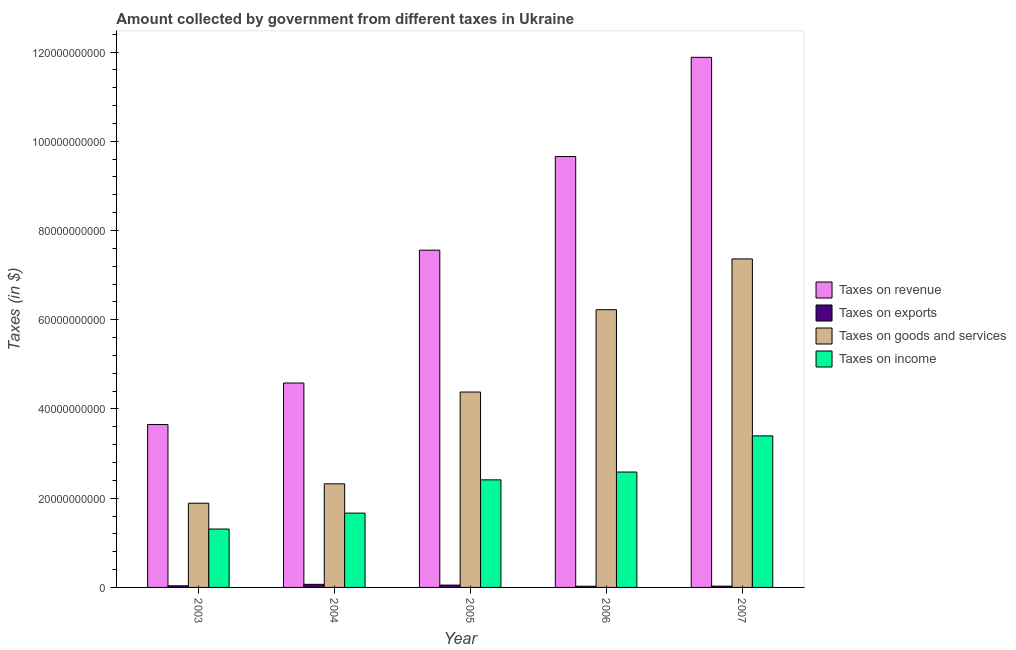How many bars are there on the 3rd tick from the left?
Make the answer very short. 4. In how many cases, is the number of bars for a given year not equal to the number of legend labels?
Your answer should be very brief. 0. What is the amount collected as tax on goods in 2004?
Ensure brevity in your answer.  2.32e+1. Across all years, what is the maximum amount collected as tax on goods?
Keep it short and to the point. 7.36e+1. Across all years, what is the minimum amount collected as tax on income?
Your answer should be very brief. 1.31e+1. In which year was the amount collected as tax on revenue minimum?
Keep it short and to the point. 2003. What is the total amount collected as tax on goods in the graph?
Give a very brief answer. 2.22e+11. What is the difference between the amount collected as tax on revenue in 2004 and that in 2006?
Your answer should be very brief. -5.08e+1. What is the difference between the amount collected as tax on income in 2007 and the amount collected as tax on exports in 2006?
Ensure brevity in your answer.  8.10e+09. What is the average amount collected as tax on revenue per year?
Ensure brevity in your answer.  7.47e+1. In how many years, is the amount collected as tax on income greater than 44000000000 $?
Keep it short and to the point. 0. What is the ratio of the amount collected as tax on income in 2003 to that in 2006?
Offer a terse response. 0.51. Is the amount collected as tax on goods in 2003 less than that in 2004?
Make the answer very short. Yes. Is the difference between the amount collected as tax on revenue in 2005 and 2006 greater than the difference between the amount collected as tax on income in 2005 and 2006?
Offer a terse response. No. What is the difference between the highest and the second highest amount collected as tax on goods?
Provide a short and direct response. 1.14e+1. What is the difference between the highest and the lowest amount collected as tax on revenue?
Keep it short and to the point. 8.23e+1. In how many years, is the amount collected as tax on income greater than the average amount collected as tax on income taken over all years?
Provide a short and direct response. 3. Is it the case that in every year, the sum of the amount collected as tax on goods and amount collected as tax on exports is greater than the sum of amount collected as tax on revenue and amount collected as tax on income?
Your answer should be compact. No. What does the 4th bar from the left in 2004 represents?
Offer a terse response. Taxes on income. What does the 2nd bar from the right in 2006 represents?
Ensure brevity in your answer.  Taxes on goods and services. Is it the case that in every year, the sum of the amount collected as tax on revenue and amount collected as tax on exports is greater than the amount collected as tax on goods?
Your response must be concise. Yes. Are all the bars in the graph horizontal?
Ensure brevity in your answer.  No. Does the graph contain grids?
Your answer should be compact. No. How many legend labels are there?
Ensure brevity in your answer.  4. How are the legend labels stacked?
Your answer should be very brief. Vertical. What is the title of the graph?
Give a very brief answer. Amount collected by government from different taxes in Ukraine. What is the label or title of the X-axis?
Offer a very short reply. Year. What is the label or title of the Y-axis?
Your answer should be compact. Taxes (in $). What is the Taxes (in $) of Taxes on revenue in 2003?
Your response must be concise. 3.65e+1. What is the Taxes (in $) of Taxes on exports in 2003?
Offer a very short reply. 3.64e+08. What is the Taxes (in $) of Taxes on goods and services in 2003?
Keep it short and to the point. 1.89e+1. What is the Taxes (in $) in Taxes on income in 2003?
Ensure brevity in your answer.  1.31e+1. What is the Taxes (in $) in Taxes on revenue in 2004?
Offer a very short reply. 4.58e+1. What is the Taxes (in $) in Taxes on exports in 2004?
Your response must be concise. 6.92e+08. What is the Taxes (in $) in Taxes on goods and services in 2004?
Provide a succinct answer. 2.32e+1. What is the Taxes (in $) of Taxes on income in 2004?
Ensure brevity in your answer.  1.67e+1. What is the Taxes (in $) of Taxes on revenue in 2005?
Keep it short and to the point. 7.56e+1. What is the Taxes (in $) in Taxes on exports in 2005?
Make the answer very short. 5.20e+08. What is the Taxes (in $) in Taxes on goods and services in 2005?
Keep it short and to the point. 4.38e+1. What is the Taxes (in $) in Taxes on income in 2005?
Offer a terse response. 2.41e+1. What is the Taxes (in $) of Taxes on revenue in 2006?
Your response must be concise. 9.66e+1. What is the Taxes (in $) of Taxes on exports in 2006?
Your answer should be very brief. 2.70e+08. What is the Taxes (in $) in Taxes on goods and services in 2006?
Give a very brief answer. 6.22e+1. What is the Taxes (in $) of Taxes on income in 2006?
Your answer should be compact. 2.59e+1. What is the Taxes (in $) of Taxes on revenue in 2007?
Your response must be concise. 1.19e+11. What is the Taxes (in $) in Taxes on exports in 2007?
Ensure brevity in your answer.  2.91e+08. What is the Taxes (in $) of Taxes on goods and services in 2007?
Your response must be concise. 7.36e+1. What is the Taxes (in $) of Taxes on income in 2007?
Ensure brevity in your answer.  3.40e+1. Across all years, what is the maximum Taxes (in $) of Taxes on revenue?
Offer a terse response. 1.19e+11. Across all years, what is the maximum Taxes (in $) in Taxes on exports?
Keep it short and to the point. 6.92e+08. Across all years, what is the maximum Taxes (in $) in Taxes on goods and services?
Provide a succinct answer. 7.36e+1. Across all years, what is the maximum Taxes (in $) of Taxes on income?
Offer a terse response. 3.40e+1. Across all years, what is the minimum Taxes (in $) of Taxes on revenue?
Your answer should be very brief. 3.65e+1. Across all years, what is the minimum Taxes (in $) of Taxes on exports?
Offer a very short reply. 2.70e+08. Across all years, what is the minimum Taxes (in $) in Taxes on goods and services?
Offer a terse response. 1.89e+1. Across all years, what is the minimum Taxes (in $) of Taxes on income?
Keep it short and to the point. 1.31e+1. What is the total Taxes (in $) in Taxes on revenue in the graph?
Your answer should be very brief. 3.73e+11. What is the total Taxes (in $) in Taxes on exports in the graph?
Offer a terse response. 2.14e+09. What is the total Taxes (in $) in Taxes on goods and services in the graph?
Provide a succinct answer. 2.22e+11. What is the total Taxes (in $) in Taxes on income in the graph?
Your answer should be compact. 1.14e+11. What is the difference between the Taxes (in $) in Taxes on revenue in 2003 and that in 2004?
Offer a terse response. -9.31e+09. What is the difference between the Taxes (in $) of Taxes on exports in 2003 and that in 2004?
Your answer should be compact. -3.27e+08. What is the difference between the Taxes (in $) of Taxes on goods and services in 2003 and that in 2004?
Offer a terse response. -4.34e+09. What is the difference between the Taxes (in $) in Taxes on income in 2003 and that in 2004?
Offer a terse response. -3.57e+09. What is the difference between the Taxes (in $) of Taxes on revenue in 2003 and that in 2005?
Keep it short and to the point. -3.91e+1. What is the difference between the Taxes (in $) of Taxes on exports in 2003 and that in 2005?
Provide a short and direct response. -1.56e+08. What is the difference between the Taxes (in $) of Taxes on goods and services in 2003 and that in 2005?
Provide a short and direct response. -2.49e+1. What is the difference between the Taxes (in $) of Taxes on income in 2003 and that in 2005?
Offer a very short reply. -1.10e+1. What is the difference between the Taxes (in $) in Taxes on revenue in 2003 and that in 2006?
Provide a short and direct response. -6.01e+1. What is the difference between the Taxes (in $) in Taxes on exports in 2003 and that in 2006?
Offer a terse response. 9.43e+07. What is the difference between the Taxes (in $) in Taxes on goods and services in 2003 and that in 2006?
Make the answer very short. -4.34e+1. What is the difference between the Taxes (in $) in Taxes on income in 2003 and that in 2006?
Provide a short and direct response. -1.28e+1. What is the difference between the Taxes (in $) in Taxes on revenue in 2003 and that in 2007?
Offer a very short reply. -8.23e+1. What is the difference between the Taxes (in $) of Taxes on exports in 2003 and that in 2007?
Make the answer very short. 7.28e+07. What is the difference between the Taxes (in $) in Taxes on goods and services in 2003 and that in 2007?
Provide a short and direct response. -5.48e+1. What is the difference between the Taxes (in $) in Taxes on income in 2003 and that in 2007?
Make the answer very short. -2.09e+1. What is the difference between the Taxes (in $) in Taxes on revenue in 2004 and that in 2005?
Make the answer very short. -2.98e+1. What is the difference between the Taxes (in $) of Taxes on exports in 2004 and that in 2005?
Provide a short and direct response. 1.71e+08. What is the difference between the Taxes (in $) of Taxes on goods and services in 2004 and that in 2005?
Your answer should be compact. -2.06e+1. What is the difference between the Taxes (in $) of Taxes on income in 2004 and that in 2005?
Make the answer very short. -7.45e+09. What is the difference between the Taxes (in $) in Taxes on revenue in 2004 and that in 2006?
Your answer should be very brief. -5.08e+1. What is the difference between the Taxes (in $) in Taxes on exports in 2004 and that in 2006?
Your response must be concise. 4.22e+08. What is the difference between the Taxes (in $) of Taxes on goods and services in 2004 and that in 2006?
Ensure brevity in your answer.  -3.90e+1. What is the difference between the Taxes (in $) of Taxes on income in 2004 and that in 2006?
Your response must be concise. -9.20e+09. What is the difference between the Taxes (in $) of Taxes on revenue in 2004 and that in 2007?
Your answer should be very brief. -7.30e+1. What is the difference between the Taxes (in $) of Taxes on exports in 2004 and that in 2007?
Provide a succinct answer. 4.00e+08. What is the difference between the Taxes (in $) in Taxes on goods and services in 2004 and that in 2007?
Offer a very short reply. -5.04e+1. What is the difference between the Taxes (in $) in Taxes on income in 2004 and that in 2007?
Make the answer very short. -1.73e+1. What is the difference between the Taxes (in $) in Taxes on revenue in 2005 and that in 2006?
Provide a short and direct response. -2.10e+1. What is the difference between the Taxes (in $) in Taxes on exports in 2005 and that in 2006?
Offer a terse response. 2.51e+08. What is the difference between the Taxes (in $) of Taxes on goods and services in 2005 and that in 2006?
Your answer should be very brief. -1.84e+1. What is the difference between the Taxes (in $) in Taxes on income in 2005 and that in 2006?
Ensure brevity in your answer.  -1.75e+09. What is the difference between the Taxes (in $) of Taxes on revenue in 2005 and that in 2007?
Offer a terse response. -4.32e+1. What is the difference between the Taxes (in $) in Taxes on exports in 2005 and that in 2007?
Provide a succinct answer. 2.29e+08. What is the difference between the Taxes (in $) in Taxes on goods and services in 2005 and that in 2007?
Make the answer very short. -2.98e+1. What is the difference between the Taxes (in $) of Taxes on income in 2005 and that in 2007?
Your answer should be very brief. -9.85e+09. What is the difference between the Taxes (in $) in Taxes on revenue in 2006 and that in 2007?
Offer a very short reply. -2.22e+1. What is the difference between the Taxes (in $) in Taxes on exports in 2006 and that in 2007?
Give a very brief answer. -2.15e+07. What is the difference between the Taxes (in $) in Taxes on goods and services in 2006 and that in 2007?
Make the answer very short. -1.14e+1. What is the difference between the Taxes (in $) of Taxes on income in 2006 and that in 2007?
Give a very brief answer. -8.10e+09. What is the difference between the Taxes (in $) of Taxes on revenue in 2003 and the Taxes (in $) of Taxes on exports in 2004?
Provide a succinct answer. 3.58e+1. What is the difference between the Taxes (in $) in Taxes on revenue in 2003 and the Taxes (in $) in Taxes on goods and services in 2004?
Your answer should be compact. 1.33e+1. What is the difference between the Taxes (in $) in Taxes on revenue in 2003 and the Taxes (in $) in Taxes on income in 2004?
Offer a terse response. 1.98e+1. What is the difference between the Taxes (in $) of Taxes on exports in 2003 and the Taxes (in $) of Taxes on goods and services in 2004?
Your response must be concise. -2.29e+1. What is the difference between the Taxes (in $) in Taxes on exports in 2003 and the Taxes (in $) in Taxes on income in 2004?
Your answer should be compact. -1.63e+1. What is the difference between the Taxes (in $) of Taxes on goods and services in 2003 and the Taxes (in $) of Taxes on income in 2004?
Your answer should be compact. 2.22e+09. What is the difference between the Taxes (in $) in Taxes on revenue in 2003 and the Taxes (in $) in Taxes on exports in 2005?
Give a very brief answer. 3.60e+1. What is the difference between the Taxes (in $) of Taxes on revenue in 2003 and the Taxes (in $) of Taxes on goods and services in 2005?
Ensure brevity in your answer.  -7.29e+09. What is the difference between the Taxes (in $) of Taxes on revenue in 2003 and the Taxes (in $) of Taxes on income in 2005?
Make the answer very short. 1.24e+1. What is the difference between the Taxes (in $) of Taxes on exports in 2003 and the Taxes (in $) of Taxes on goods and services in 2005?
Provide a succinct answer. -4.34e+1. What is the difference between the Taxes (in $) of Taxes on exports in 2003 and the Taxes (in $) of Taxes on income in 2005?
Offer a very short reply. -2.37e+1. What is the difference between the Taxes (in $) in Taxes on goods and services in 2003 and the Taxes (in $) in Taxes on income in 2005?
Offer a very short reply. -5.23e+09. What is the difference between the Taxes (in $) in Taxes on revenue in 2003 and the Taxes (in $) in Taxes on exports in 2006?
Offer a terse response. 3.62e+1. What is the difference between the Taxes (in $) in Taxes on revenue in 2003 and the Taxes (in $) in Taxes on goods and services in 2006?
Keep it short and to the point. -2.57e+1. What is the difference between the Taxes (in $) in Taxes on revenue in 2003 and the Taxes (in $) in Taxes on income in 2006?
Keep it short and to the point. 1.06e+1. What is the difference between the Taxes (in $) of Taxes on exports in 2003 and the Taxes (in $) of Taxes on goods and services in 2006?
Your response must be concise. -6.19e+1. What is the difference between the Taxes (in $) of Taxes on exports in 2003 and the Taxes (in $) of Taxes on income in 2006?
Provide a short and direct response. -2.55e+1. What is the difference between the Taxes (in $) of Taxes on goods and services in 2003 and the Taxes (in $) of Taxes on income in 2006?
Ensure brevity in your answer.  -6.99e+09. What is the difference between the Taxes (in $) of Taxes on revenue in 2003 and the Taxes (in $) of Taxes on exports in 2007?
Offer a terse response. 3.62e+1. What is the difference between the Taxes (in $) of Taxes on revenue in 2003 and the Taxes (in $) of Taxes on goods and services in 2007?
Make the answer very short. -3.71e+1. What is the difference between the Taxes (in $) of Taxes on revenue in 2003 and the Taxes (in $) of Taxes on income in 2007?
Provide a short and direct response. 2.54e+09. What is the difference between the Taxes (in $) in Taxes on exports in 2003 and the Taxes (in $) in Taxes on goods and services in 2007?
Your response must be concise. -7.33e+1. What is the difference between the Taxes (in $) of Taxes on exports in 2003 and the Taxes (in $) of Taxes on income in 2007?
Provide a short and direct response. -3.36e+1. What is the difference between the Taxes (in $) of Taxes on goods and services in 2003 and the Taxes (in $) of Taxes on income in 2007?
Offer a terse response. -1.51e+1. What is the difference between the Taxes (in $) in Taxes on revenue in 2004 and the Taxes (in $) in Taxes on exports in 2005?
Provide a succinct answer. 4.53e+1. What is the difference between the Taxes (in $) in Taxes on revenue in 2004 and the Taxes (in $) in Taxes on goods and services in 2005?
Your answer should be very brief. 2.02e+09. What is the difference between the Taxes (in $) in Taxes on revenue in 2004 and the Taxes (in $) in Taxes on income in 2005?
Offer a terse response. 2.17e+1. What is the difference between the Taxes (in $) in Taxes on exports in 2004 and the Taxes (in $) in Taxes on goods and services in 2005?
Your answer should be compact. -4.31e+1. What is the difference between the Taxes (in $) of Taxes on exports in 2004 and the Taxes (in $) of Taxes on income in 2005?
Ensure brevity in your answer.  -2.34e+1. What is the difference between the Taxes (in $) in Taxes on goods and services in 2004 and the Taxes (in $) in Taxes on income in 2005?
Make the answer very short. -8.90e+08. What is the difference between the Taxes (in $) in Taxes on revenue in 2004 and the Taxes (in $) in Taxes on exports in 2006?
Provide a short and direct response. 4.55e+1. What is the difference between the Taxes (in $) of Taxes on revenue in 2004 and the Taxes (in $) of Taxes on goods and services in 2006?
Your answer should be very brief. -1.64e+1. What is the difference between the Taxes (in $) of Taxes on revenue in 2004 and the Taxes (in $) of Taxes on income in 2006?
Keep it short and to the point. 2.00e+1. What is the difference between the Taxes (in $) of Taxes on exports in 2004 and the Taxes (in $) of Taxes on goods and services in 2006?
Ensure brevity in your answer.  -6.16e+1. What is the difference between the Taxes (in $) in Taxes on exports in 2004 and the Taxes (in $) in Taxes on income in 2006?
Ensure brevity in your answer.  -2.52e+1. What is the difference between the Taxes (in $) in Taxes on goods and services in 2004 and the Taxes (in $) in Taxes on income in 2006?
Provide a short and direct response. -2.64e+09. What is the difference between the Taxes (in $) of Taxes on revenue in 2004 and the Taxes (in $) of Taxes on exports in 2007?
Provide a short and direct response. 4.55e+1. What is the difference between the Taxes (in $) of Taxes on revenue in 2004 and the Taxes (in $) of Taxes on goods and services in 2007?
Provide a short and direct response. -2.78e+1. What is the difference between the Taxes (in $) of Taxes on revenue in 2004 and the Taxes (in $) of Taxes on income in 2007?
Offer a very short reply. 1.19e+1. What is the difference between the Taxes (in $) of Taxes on exports in 2004 and the Taxes (in $) of Taxes on goods and services in 2007?
Give a very brief answer. -7.29e+1. What is the difference between the Taxes (in $) in Taxes on exports in 2004 and the Taxes (in $) in Taxes on income in 2007?
Ensure brevity in your answer.  -3.33e+1. What is the difference between the Taxes (in $) in Taxes on goods and services in 2004 and the Taxes (in $) in Taxes on income in 2007?
Make the answer very short. -1.07e+1. What is the difference between the Taxes (in $) in Taxes on revenue in 2005 and the Taxes (in $) in Taxes on exports in 2006?
Give a very brief answer. 7.53e+1. What is the difference between the Taxes (in $) of Taxes on revenue in 2005 and the Taxes (in $) of Taxes on goods and services in 2006?
Offer a very short reply. 1.33e+1. What is the difference between the Taxes (in $) in Taxes on revenue in 2005 and the Taxes (in $) in Taxes on income in 2006?
Make the answer very short. 4.97e+1. What is the difference between the Taxes (in $) of Taxes on exports in 2005 and the Taxes (in $) of Taxes on goods and services in 2006?
Your answer should be compact. -6.17e+1. What is the difference between the Taxes (in $) of Taxes on exports in 2005 and the Taxes (in $) of Taxes on income in 2006?
Your answer should be very brief. -2.53e+1. What is the difference between the Taxes (in $) of Taxes on goods and services in 2005 and the Taxes (in $) of Taxes on income in 2006?
Offer a very short reply. 1.79e+1. What is the difference between the Taxes (in $) in Taxes on revenue in 2005 and the Taxes (in $) in Taxes on exports in 2007?
Your response must be concise. 7.53e+1. What is the difference between the Taxes (in $) in Taxes on revenue in 2005 and the Taxes (in $) in Taxes on goods and services in 2007?
Offer a very short reply. 1.96e+09. What is the difference between the Taxes (in $) of Taxes on revenue in 2005 and the Taxes (in $) of Taxes on income in 2007?
Keep it short and to the point. 4.16e+1. What is the difference between the Taxes (in $) in Taxes on exports in 2005 and the Taxes (in $) in Taxes on goods and services in 2007?
Offer a terse response. -7.31e+1. What is the difference between the Taxes (in $) of Taxes on exports in 2005 and the Taxes (in $) of Taxes on income in 2007?
Offer a terse response. -3.34e+1. What is the difference between the Taxes (in $) in Taxes on goods and services in 2005 and the Taxes (in $) in Taxes on income in 2007?
Give a very brief answer. 9.83e+09. What is the difference between the Taxes (in $) in Taxes on revenue in 2006 and the Taxes (in $) in Taxes on exports in 2007?
Your response must be concise. 9.63e+1. What is the difference between the Taxes (in $) in Taxes on revenue in 2006 and the Taxes (in $) in Taxes on goods and services in 2007?
Provide a succinct answer. 2.29e+1. What is the difference between the Taxes (in $) of Taxes on revenue in 2006 and the Taxes (in $) of Taxes on income in 2007?
Ensure brevity in your answer.  6.26e+1. What is the difference between the Taxes (in $) of Taxes on exports in 2006 and the Taxes (in $) of Taxes on goods and services in 2007?
Provide a succinct answer. -7.34e+1. What is the difference between the Taxes (in $) of Taxes on exports in 2006 and the Taxes (in $) of Taxes on income in 2007?
Offer a very short reply. -3.37e+1. What is the difference between the Taxes (in $) of Taxes on goods and services in 2006 and the Taxes (in $) of Taxes on income in 2007?
Your answer should be compact. 2.83e+1. What is the average Taxes (in $) in Taxes on revenue per year?
Offer a terse response. 7.47e+1. What is the average Taxes (in $) of Taxes on exports per year?
Your response must be concise. 4.28e+08. What is the average Taxes (in $) in Taxes on goods and services per year?
Make the answer very short. 4.44e+1. What is the average Taxes (in $) of Taxes on income per year?
Your response must be concise. 2.27e+1. In the year 2003, what is the difference between the Taxes (in $) of Taxes on revenue and Taxes (in $) of Taxes on exports?
Your answer should be compact. 3.61e+1. In the year 2003, what is the difference between the Taxes (in $) in Taxes on revenue and Taxes (in $) in Taxes on goods and services?
Offer a terse response. 1.76e+1. In the year 2003, what is the difference between the Taxes (in $) in Taxes on revenue and Taxes (in $) in Taxes on income?
Keep it short and to the point. 2.34e+1. In the year 2003, what is the difference between the Taxes (in $) in Taxes on exports and Taxes (in $) in Taxes on goods and services?
Give a very brief answer. -1.85e+1. In the year 2003, what is the difference between the Taxes (in $) of Taxes on exports and Taxes (in $) of Taxes on income?
Provide a succinct answer. -1.27e+1. In the year 2003, what is the difference between the Taxes (in $) in Taxes on goods and services and Taxes (in $) in Taxes on income?
Ensure brevity in your answer.  5.79e+09. In the year 2004, what is the difference between the Taxes (in $) of Taxes on revenue and Taxes (in $) of Taxes on exports?
Ensure brevity in your answer.  4.51e+1. In the year 2004, what is the difference between the Taxes (in $) of Taxes on revenue and Taxes (in $) of Taxes on goods and services?
Keep it short and to the point. 2.26e+1. In the year 2004, what is the difference between the Taxes (in $) of Taxes on revenue and Taxes (in $) of Taxes on income?
Keep it short and to the point. 2.92e+1. In the year 2004, what is the difference between the Taxes (in $) in Taxes on exports and Taxes (in $) in Taxes on goods and services?
Keep it short and to the point. -2.25e+1. In the year 2004, what is the difference between the Taxes (in $) of Taxes on exports and Taxes (in $) of Taxes on income?
Your answer should be compact. -1.60e+1. In the year 2004, what is the difference between the Taxes (in $) of Taxes on goods and services and Taxes (in $) of Taxes on income?
Offer a very short reply. 6.56e+09. In the year 2005, what is the difference between the Taxes (in $) in Taxes on revenue and Taxes (in $) in Taxes on exports?
Your response must be concise. 7.51e+1. In the year 2005, what is the difference between the Taxes (in $) of Taxes on revenue and Taxes (in $) of Taxes on goods and services?
Keep it short and to the point. 3.18e+1. In the year 2005, what is the difference between the Taxes (in $) in Taxes on revenue and Taxes (in $) in Taxes on income?
Provide a short and direct response. 5.15e+1. In the year 2005, what is the difference between the Taxes (in $) in Taxes on exports and Taxes (in $) in Taxes on goods and services?
Your answer should be compact. -4.33e+1. In the year 2005, what is the difference between the Taxes (in $) in Taxes on exports and Taxes (in $) in Taxes on income?
Your answer should be very brief. -2.36e+1. In the year 2005, what is the difference between the Taxes (in $) of Taxes on goods and services and Taxes (in $) of Taxes on income?
Give a very brief answer. 1.97e+1. In the year 2006, what is the difference between the Taxes (in $) in Taxes on revenue and Taxes (in $) in Taxes on exports?
Your answer should be compact. 9.63e+1. In the year 2006, what is the difference between the Taxes (in $) of Taxes on revenue and Taxes (in $) of Taxes on goods and services?
Provide a short and direct response. 3.43e+1. In the year 2006, what is the difference between the Taxes (in $) in Taxes on revenue and Taxes (in $) in Taxes on income?
Offer a terse response. 7.07e+1. In the year 2006, what is the difference between the Taxes (in $) of Taxes on exports and Taxes (in $) of Taxes on goods and services?
Keep it short and to the point. -6.20e+1. In the year 2006, what is the difference between the Taxes (in $) in Taxes on exports and Taxes (in $) in Taxes on income?
Keep it short and to the point. -2.56e+1. In the year 2006, what is the difference between the Taxes (in $) in Taxes on goods and services and Taxes (in $) in Taxes on income?
Your response must be concise. 3.64e+1. In the year 2007, what is the difference between the Taxes (in $) in Taxes on revenue and Taxes (in $) in Taxes on exports?
Keep it short and to the point. 1.19e+11. In the year 2007, what is the difference between the Taxes (in $) of Taxes on revenue and Taxes (in $) of Taxes on goods and services?
Give a very brief answer. 4.52e+1. In the year 2007, what is the difference between the Taxes (in $) in Taxes on revenue and Taxes (in $) in Taxes on income?
Give a very brief answer. 8.48e+1. In the year 2007, what is the difference between the Taxes (in $) of Taxes on exports and Taxes (in $) of Taxes on goods and services?
Offer a terse response. -7.33e+1. In the year 2007, what is the difference between the Taxes (in $) in Taxes on exports and Taxes (in $) in Taxes on income?
Provide a succinct answer. -3.37e+1. In the year 2007, what is the difference between the Taxes (in $) in Taxes on goods and services and Taxes (in $) in Taxes on income?
Provide a succinct answer. 3.97e+1. What is the ratio of the Taxes (in $) in Taxes on revenue in 2003 to that in 2004?
Provide a succinct answer. 0.8. What is the ratio of the Taxes (in $) of Taxes on exports in 2003 to that in 2004?
Keep it short and to the point. 0.53. What is the ratio of the Taxes (in $) of Taxes on goods and services in 2003 to that in 2004?
Keep it short and to the point. 0.81. What is the ratio of the Taxes (in $) of Taxes on income in 2003 to that in 2004?
Your response must be concise. 0.79. What is the ratio of the Taxes (in $) of Taxes on revenue in 2003 to that in 2005?
Provide a succinct answer. 0.48. What is the ratio of the Taxes (in $) of Taxes on exports in 2003 to that in 2005?
Your response must be concise. 0.7. What is the ratio of the Taxes (in $) of Taxes on goods and services in 2003 to that in 2005?
Offer a very short reply. 0.43. What is the ratio of the Taxes (in $) in Taxes on income in 2003 to that in 2005?
Offer a terse response. 0.54. What is the ratio of the Taxes (in $) in Taxes on revenue in 2003 to that in 2006?
Make the answer very short. 0.38. What is the ratio of the Taxes (in $) of Taxes on exports in 2003 to that in 2006?
Your answer should be very brief. 1.35. What is the ratio of the Taxes (in $) of Taxes on goods and services in 2003 to that in 2006?
Your response must be concise. 0.3. What is the ratio of the Taxes (in $) in Taxes on income in 2003 to that in 2006?
Give a very brief answer. 0.51. What is the ratio of the Taxes (in $) of Taxes on revenue in 2003 to that in 2007?
Offer a very short reply. 0.31. What is the ratio of the Taxes (in $) of Taxes on exports in 2003 to that in 2007?
Keep it short and to the point. 1.25. What is the ratio of the Taxes (in $) of Taxes on goods and services in 2003 to that in 2007?
Provide a short and direct response. 0.26. What is the ratio of the Taxes (in $) in Taxes on income in 2003 to that in 2007?
Your answer should be compact. 0.39. What is the ratio of the Taxes (in $) of Taxes on revenue in 2004 to that in 2005?
Offer a terse response. 0.61. What is the ratio of the Taxes (in $) in Taxes on exports in 2004 to that in 2005?
Provide a succinct answer. 1.33. What is the ratio of the Taxes (in $) of Taxes on goods and services in 2004 to that in 2005?
Keep it short and to the point. 0.53. What is the ratio of the Taxes (in $) in Taxes on income in 2004 to that in 2005?
Your answer should be compact. 0.69. What is the ratio of the Taxes (in $) in Taxes on revenue in 2004 to that in 2006?
Make the answer very short. 0.47. What is the ratio of the Taxes (in $) of Taxes on exports in 2004 to that in 2006?
Keep it short and to the point. 2.56. What is the ratio of the Taxes (in $) in Taxes on goods and services in 2004 to that in 2006?
Make the answer very short. 0.37. What is the ratio of the Taxes (in $) in Taxes on income in 2004 to that in 2006?
Provide a succinct answer. 0.64. What is the ratio of the Taxes (in $) of Taxes on revenue in 2004 to that in 2007?
Provide a short and direct response. 0.39. What is the ratio of the Taxes (in $) of Taxes on exports in 2004 to that in 2007?
Make the answer very short. 2.37. What is the ratio of the Taxes (in $) of Taxes on goods and services in 2004 to that in 2007?
Offer a very short reply. 0.32. What is the ratio of the Taxes (in $) of Taxes on income in 2004 to that in 2007?
Provide a succinct answer. 0.49. What is the ratio of the Taxes (in $) of Taxes on revenue in 2005 to that in 2006?
Provide a short and direct response. 0.78. What is the ratio of the Taxes (in $) in Taxes on exports in 2005 to that in 2006?
Provide a short and direct response. 1.93. What is the ratio of the Taxes (in $) of Taxes on goods and services in 2005 to that in 2006?
Offer a terse response. 0.7. What is the ratio of the Taxes (in $) in Taxes on income in 2005 to that in 2006?
Ensure brevity in your answer.  0.93. What is the ratio of the Taxes (in $) in Taxes on revenue in 2005 to that in 2007?
Your response must be concise. 0.64. What is the ratio of the Taxes (in $) in Taxes on exports in 2005 to that in 2007?
Give a very brief answer. 1.79. What is the ratio of the Taxes (in $) in Taxes on goods and services in 2005 to that in 2007?
Make the answer very short. 0.59. What is the ratio of the Taxes (in $) in Taxes on income in 2005 to that in 2007?
Your response must be concise. 0.71. What is the ratio of the Taxes (in $) in Taxes on revenue in 2006 to that in 2007?
Keep it short and to the point. 0.81. What is the ratio of the Taxes (in $) of Taxes on exports in 2006 to that in 2007?
Ensure brevity in your answer.  0.93. What is the ratio of the Taxes (in $) in Taxes on goods and services in 2006 to that in 2007?
Ensure brevity in your answer.  0.85. What is the ratio of the Taxes (in $) of Taxes on income in 2006 to that in 2007?
Your response must be concise. 0.76. What is the difference between the highest and the second highest Taxes (in $) in Taxes on revenue?
Your response must be concise. 2.22e+1. What is the difference between the highest and the second highest Taxes (in $) in Taxes on exports?
Ensure brevity in your answer.  1.71e+08. What is the difference between the highest and the second highest Taxes (in $) of Taxes on goods and services?
Your response must be concise. 1.14e+1. What is the difference between the highest and the second highest Taxes (in $) of Taxes on income?
Offer a terse response. 8.10e+09. What is the difference between the highest and the lowest Taxes (in $) in Taxes on revenue?
Provide a succinct answer. 8.23e+1. What is the difference between the highest and the lowest Taxes (in $) in Taxes on exports?
Give a very brief answer. 4.22e+08. What is the difference between the highest and the lowest Taxes (in $) of Taxes on goods and services?
Your answer should be very brief. 5.48e+1. What is the difference between the highest and the lowest Taxes (in $) of Taxes on income?
Your response must be concise. 2.09e+1. 